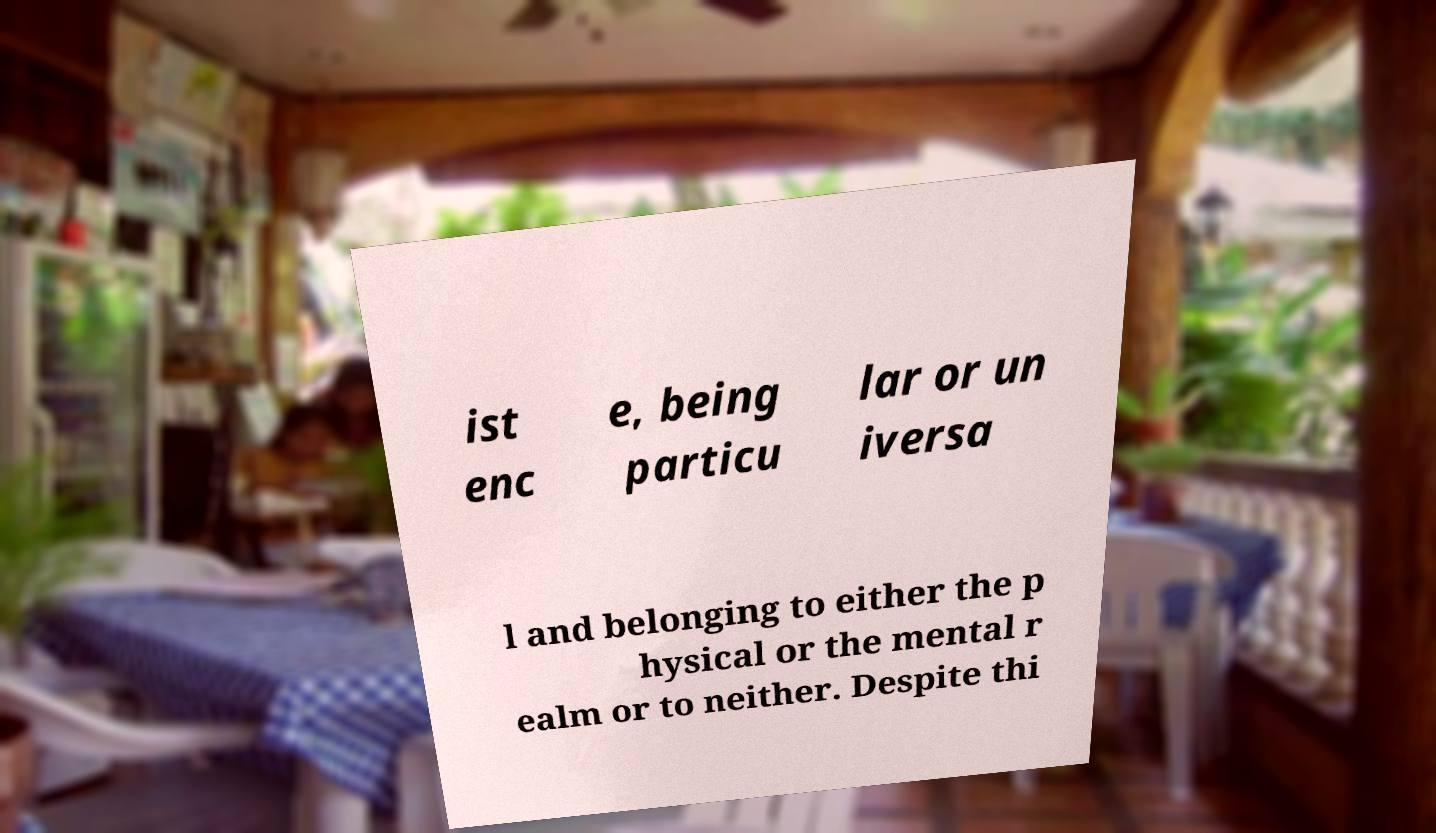Could you extract and type out the text from this image? ist enc e, being particu lar or un iversa l and belonging to either the p hysical or the mental r ealm or to neither. Despite thi 